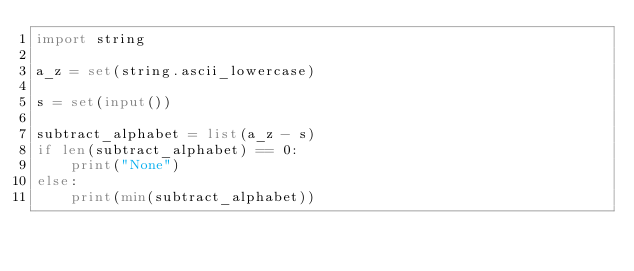Convert code to text. <code><loc_0><loc_0><loc_500><loc_500><_Python_>import string

a_z = set(string.ascii_lowercase)

s = set(input())

subtract_alphabet = list(a_z - s)
if len(subtract_alphabet) == 0:
    print("None")
else:
    print(min(subtract_alphabet))

</code> 